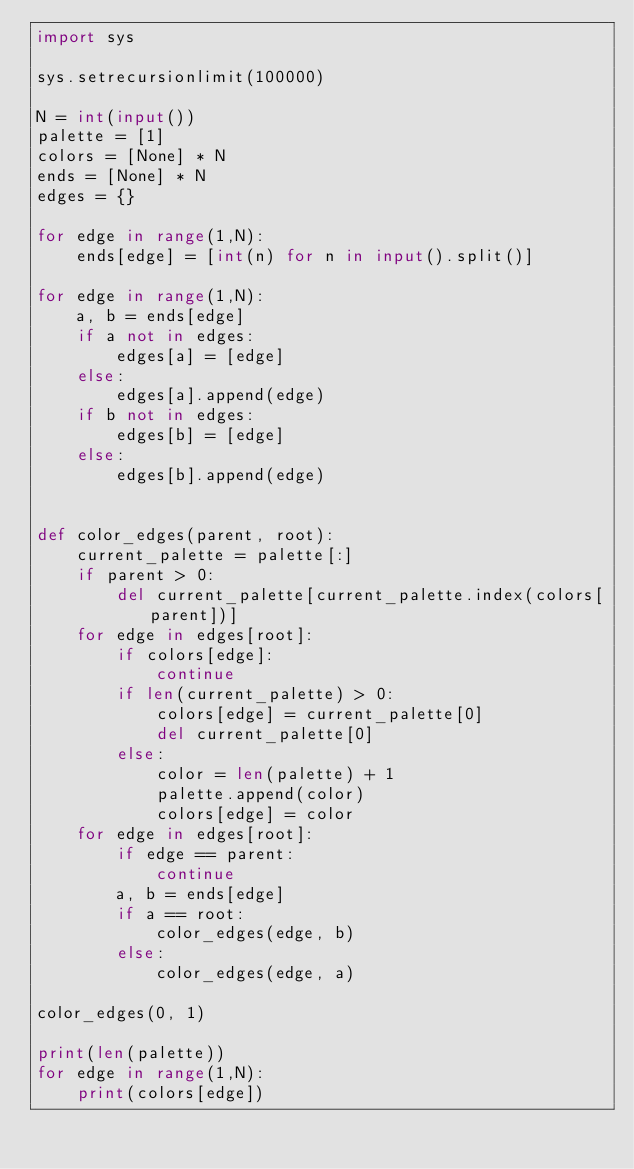Convert code to text. <code><loc_0><loc_0><loc_500><loc_500><_Python_>import sys

sys.setrecursionlimit(100000)

N = int(input())
palette = [1]
colors = [None] * N
ends = [None] * N
edges = {}

for edge in range(1,N):
    ends[edge] = [int(n) for n in input().split()]

for edge in range(1,N):
    a, b = ends[edge]
    if a not in edges:
        edges[a] = [edge]
    else:
        edges[a].append(edge)
    if b not in edges:
        edges[b] = [edge]
    else:
        edges[b].append(edge)


def color_edges(parent, root):
    current_palette = palette[:]
    if parent > 0:
        del current_palette[current_palette.index(colors[parent])]
    for edge in edges[root]:
        if colors[edge]:
            continue
        if len(current_palette) > 0:
            colors[edge] = current_palette[0]
            del current_palette[0]
        else:
            color = len(palette) + 1
            palette.append(color)
            colors[edge] = color
    for edge in edges[root]:
        if edge == parent:
            continue
        a, b = ends[edge]
        if a == root:
            color_edges(edge, b)
        else:
            color_edges(edge, a)

color_edges(0, 1)

print(len(palette))
for edge in range(1,N):
    print(colors[edge])
</code> 